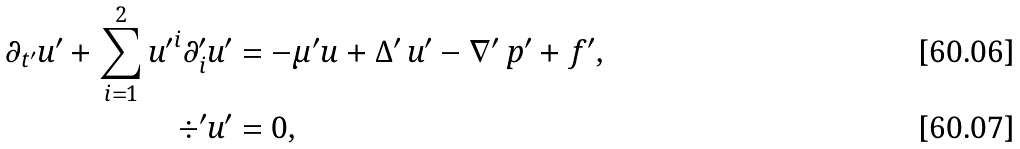Convert formula to latex. <formula><loc_0><loc_0><loc_500><loc_500>\partial _ { t ^ { \prime } } u ^ { \prime } + \sum _ { i = 1 } ^ { 2 } { u ^ { \prime } } ^ { i } \partial ^ { \prime } _ { i } u ^ { \prime } & = - \mu ^ { \prime } u + \Delta ^ { \prime } \, u ^ { \prime } - \nabla ^ { \prime } \, p ^ { \prime } + f ^ { \prime } , \\ { \div } ^ { \prime } u ^ { \prime } & = 0 ,</formula> 